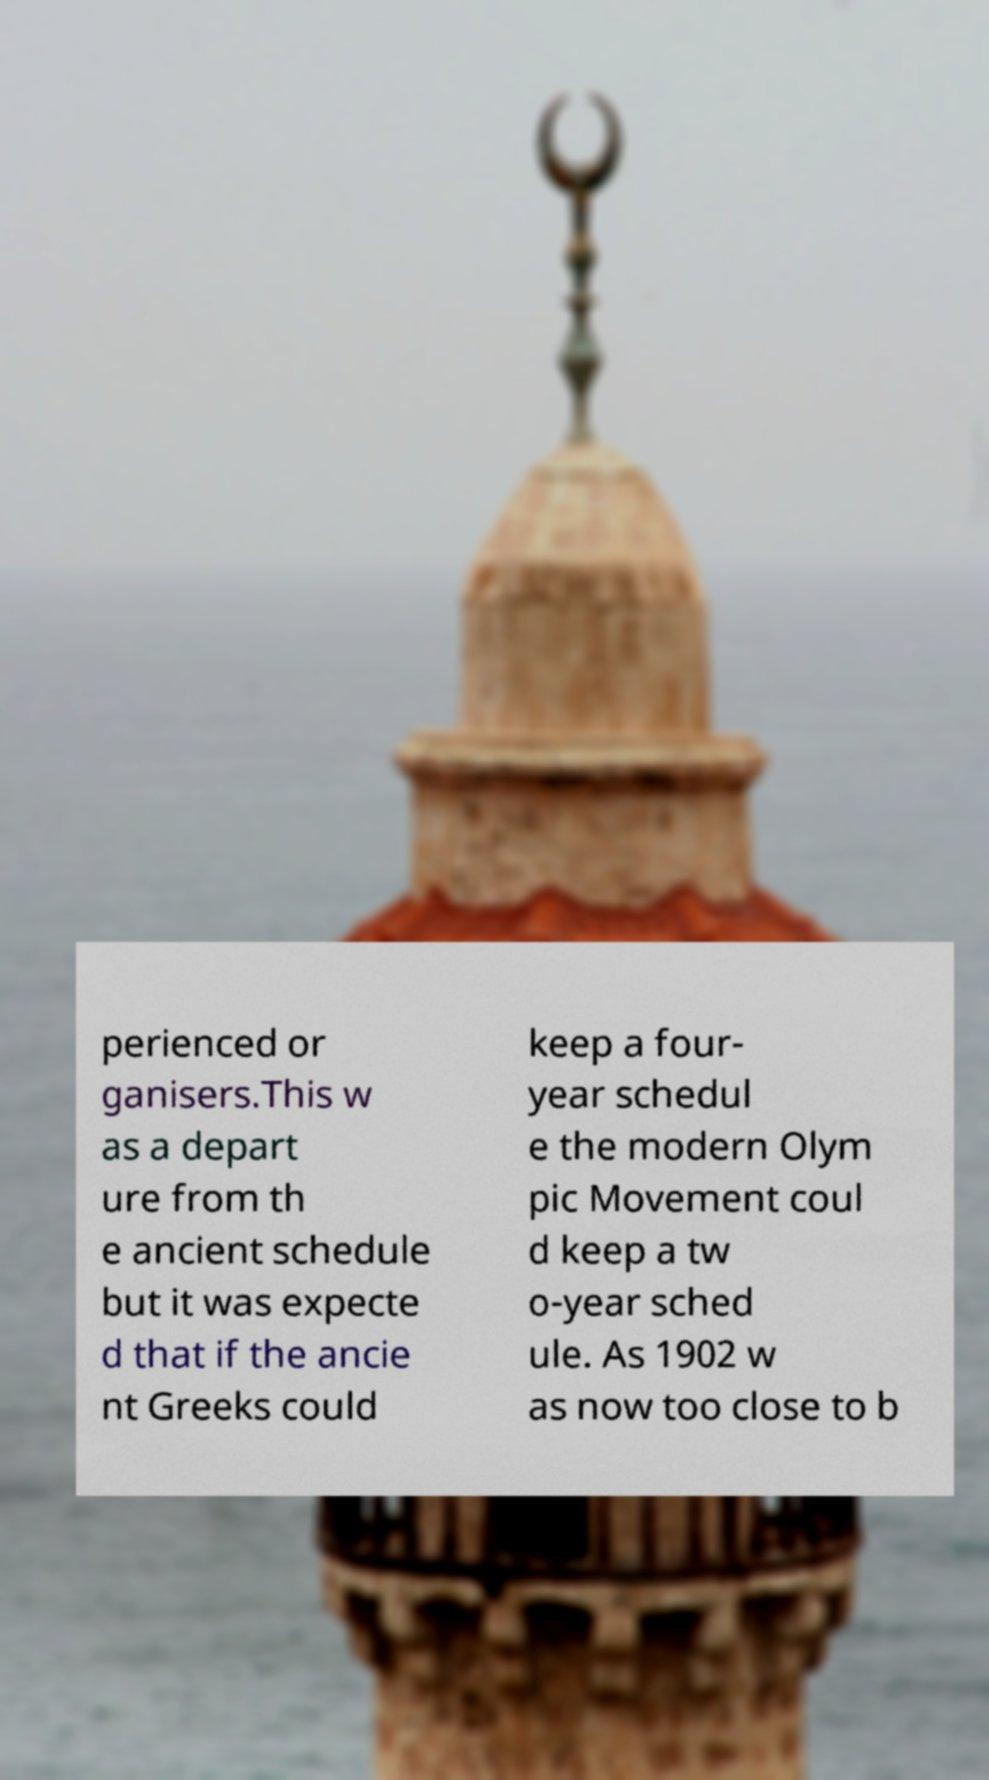There's text embedded in this image that I need extracted. Can you transcribe it verbatim? perienced or ganisers.This w as a depart ure from th e ancient schedule but it was expecte d that if the ancie nt Greeks could keep a four- year schedul e the modern Olym pic Movement coul d keep a tw o-year sched ule. As 1902 w as now too close to b 